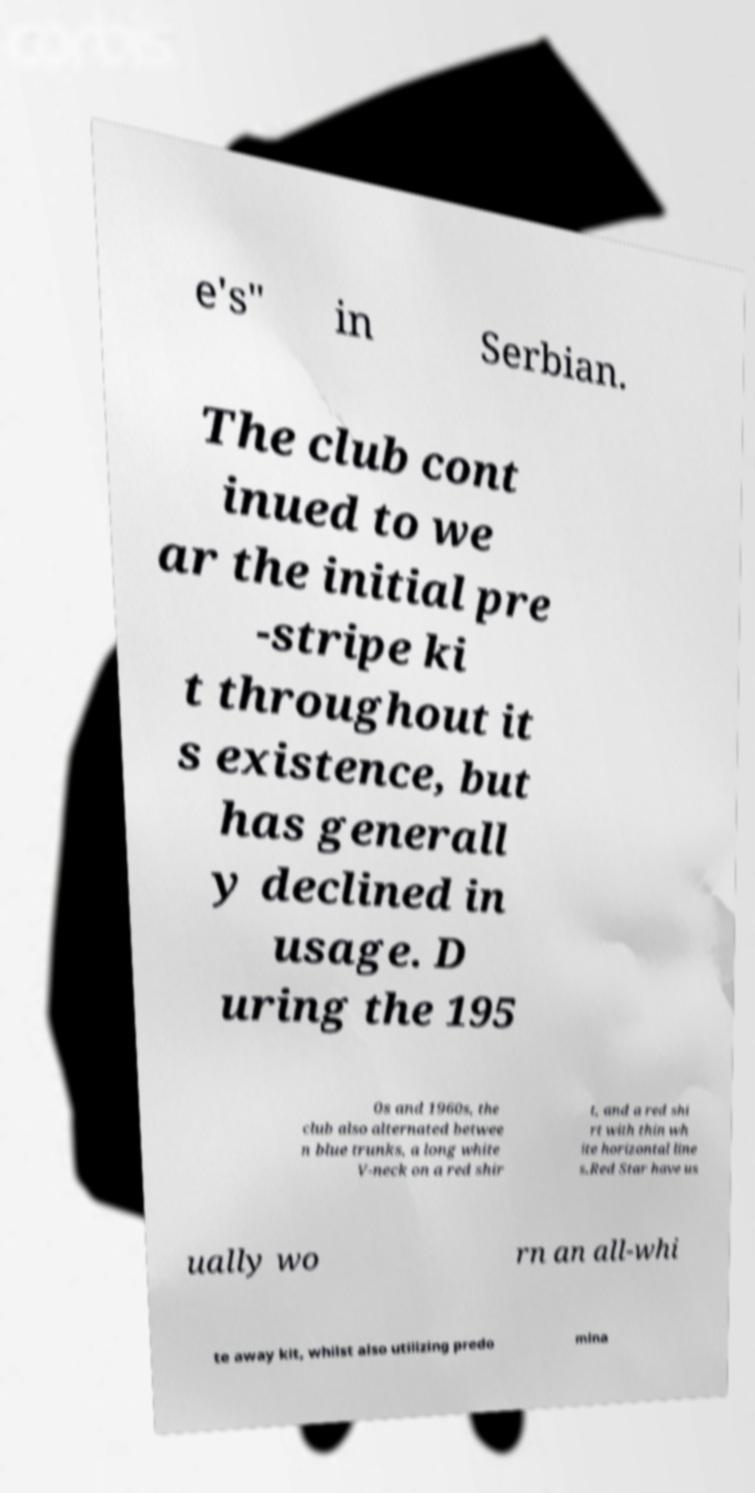What messages or text are displayed in this image? I need them in a readable, typed format. e's" in Serbian. The club cont inued to we ar the initial pre -stripe ki t throughout it s existence, but has generall y declined in usage. D uring the 195 0s and 1960s, the club also alternated betwee n blue trunks, a long white V-neck on a red shir t, and a red shi rt with thin wh ite horizontal line s.Red Star have us ually wo rn an all-whi te away kit, whilst also utilizing predo mina 